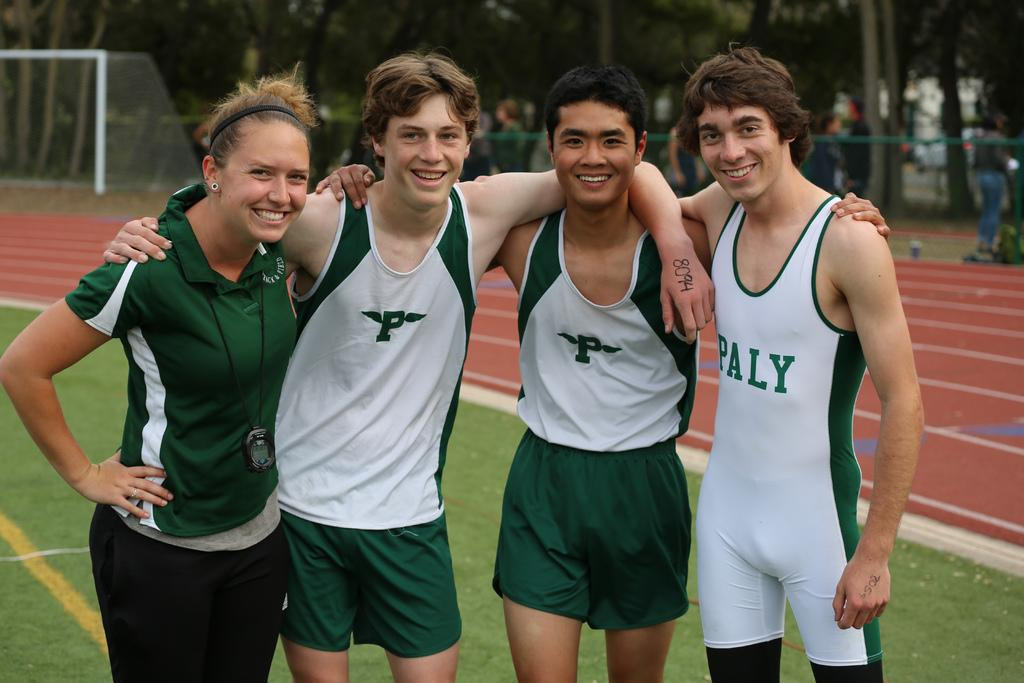Provide a one-sentence caption for the provided image. Three boys and a female pose for their picture together wearing clothes that either have P or Paly on them. 